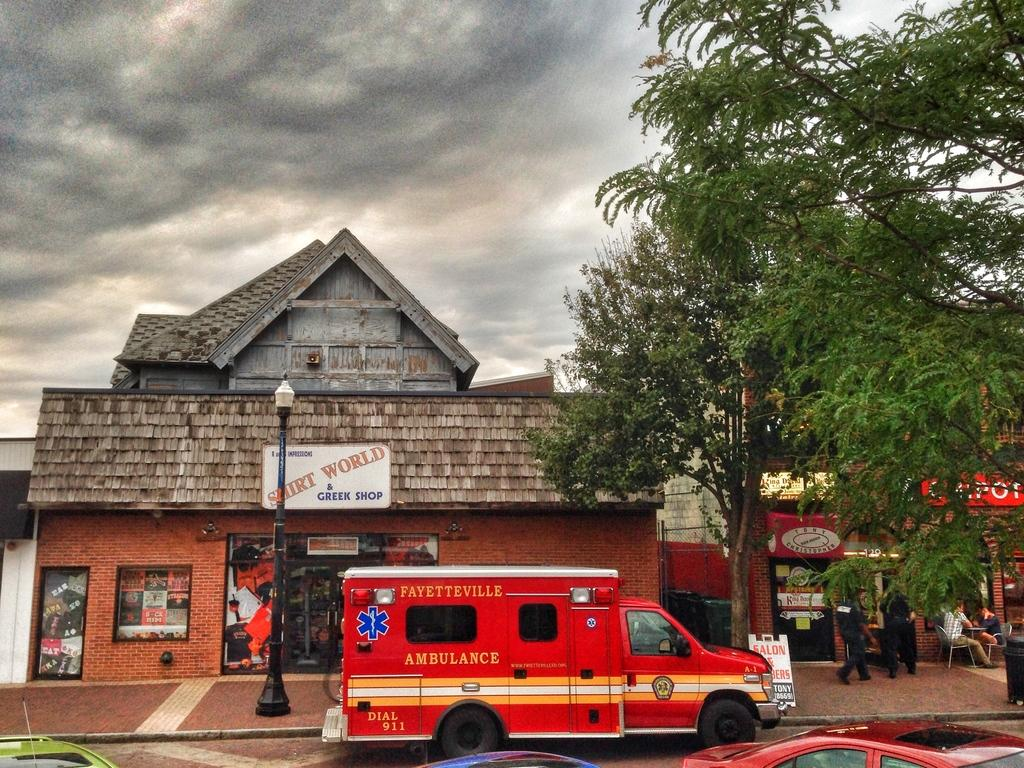What type of structures can be seen in the image? There are buildings in the image. What is happening on the road in the image? There are vehicles on the road in the image. What is the purpose of the object on the side of the road? A street light is present in the image to provide illumination. What type of plant is visible in the image? There is a tree in the image. What can be seen in the sky in the image? There are clouds visible in the sky in the image. What shape is the sheet hanging from the hook in the image? There is no sheet or hook present in the image. How many hooks are visible in the image? There are no hooks visible in the image. 